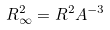<formula> <loc_0><loc_0><loc_500><loc_500>R _ { \infty } ^ { 2 } = R ^ { 2 } A ^ { - 3 }</formula> 